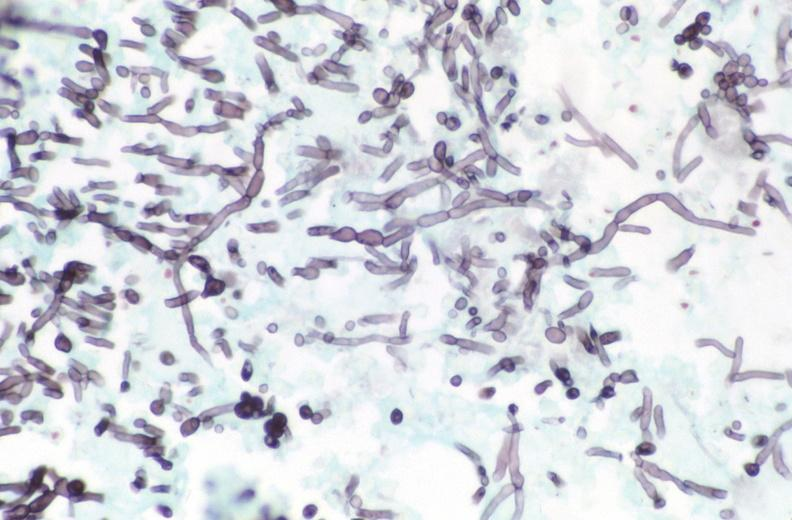what stain?
Answer the question using a single word or phrase. Silver 